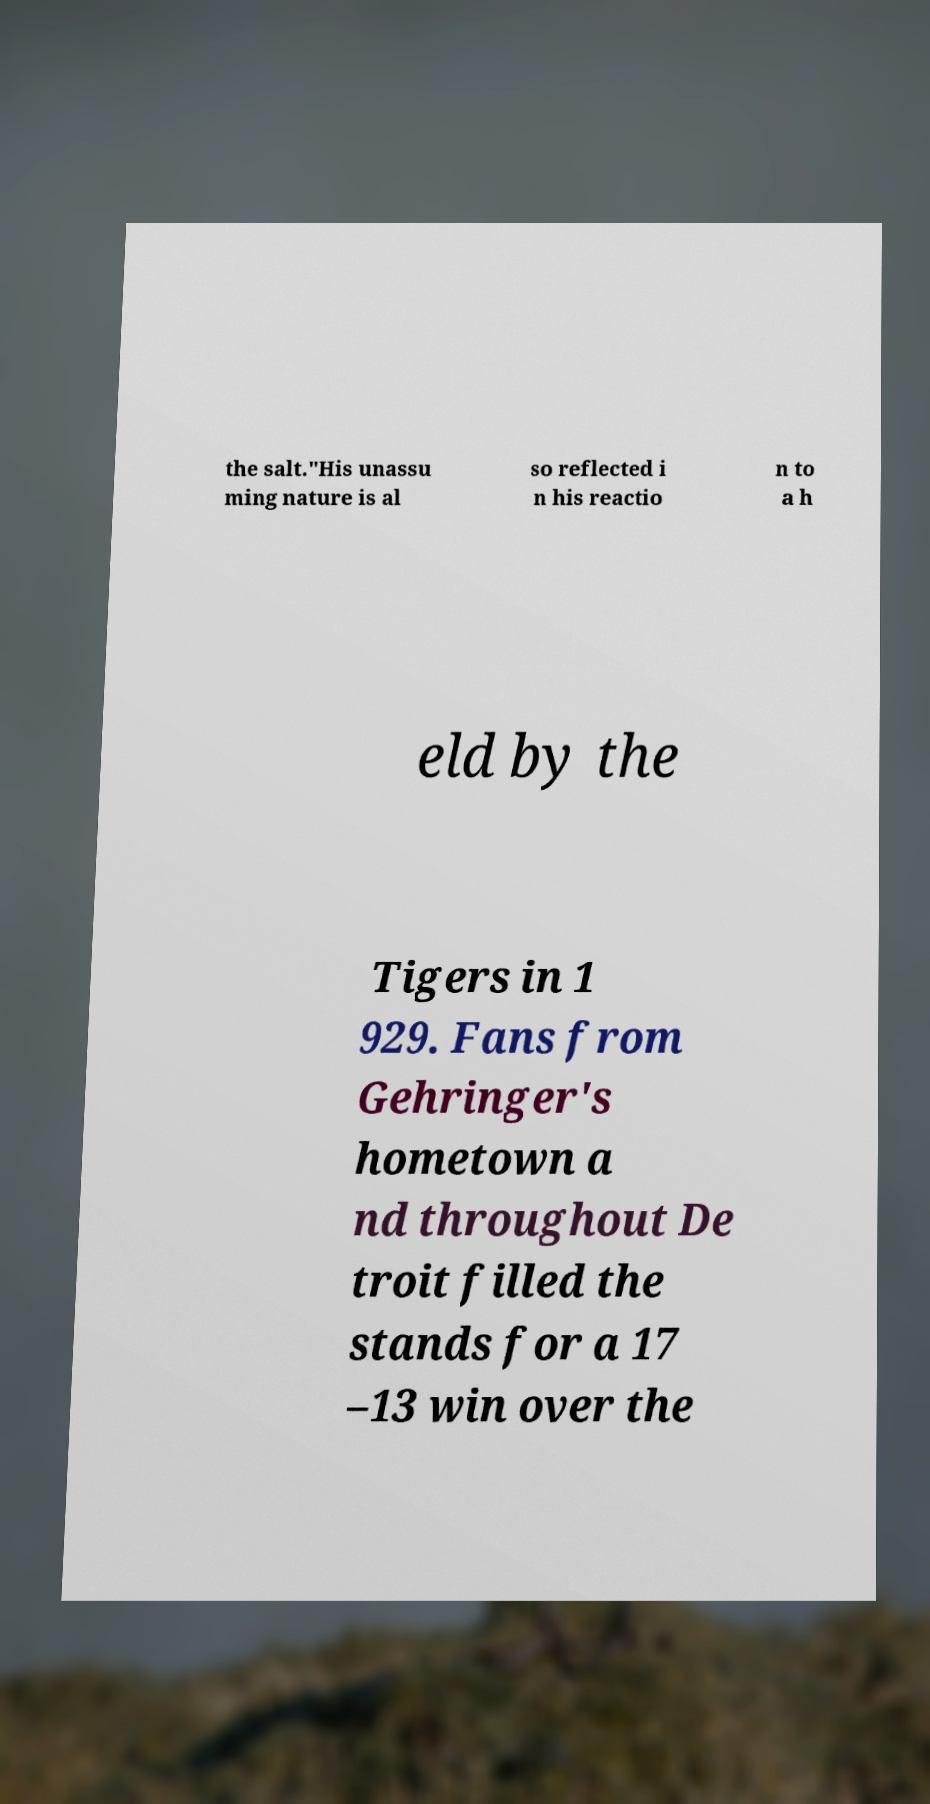Please read and relay the text visible in this image. What does it say? the salt."His unassu ming nature is al so reflected i n his reactio n to a h eld by the Tigers in 1 929. Fans from Gehringer's hometown a nd throughout De troit filled the stands for a 17 –13 win over the 